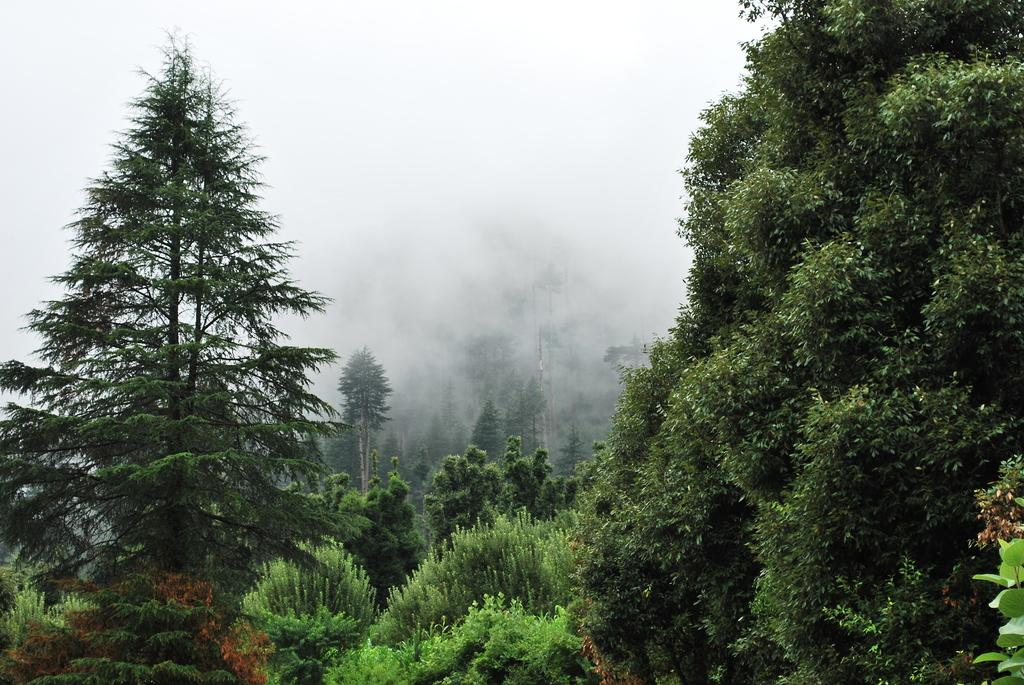What type of vegetation is visible in the image? There are trees in the image. What atmospheric condition can be observed in the image? There appears to be fog at the back of the image. What type of gate is present in the image? There is no gate present in the image; it only features trees and fog. What arithmetic problem can be solved using the trees in the image? The trees in the image are not related to any arithmetic problem, as they are natural elements and not mathematical symbols or concepts. 